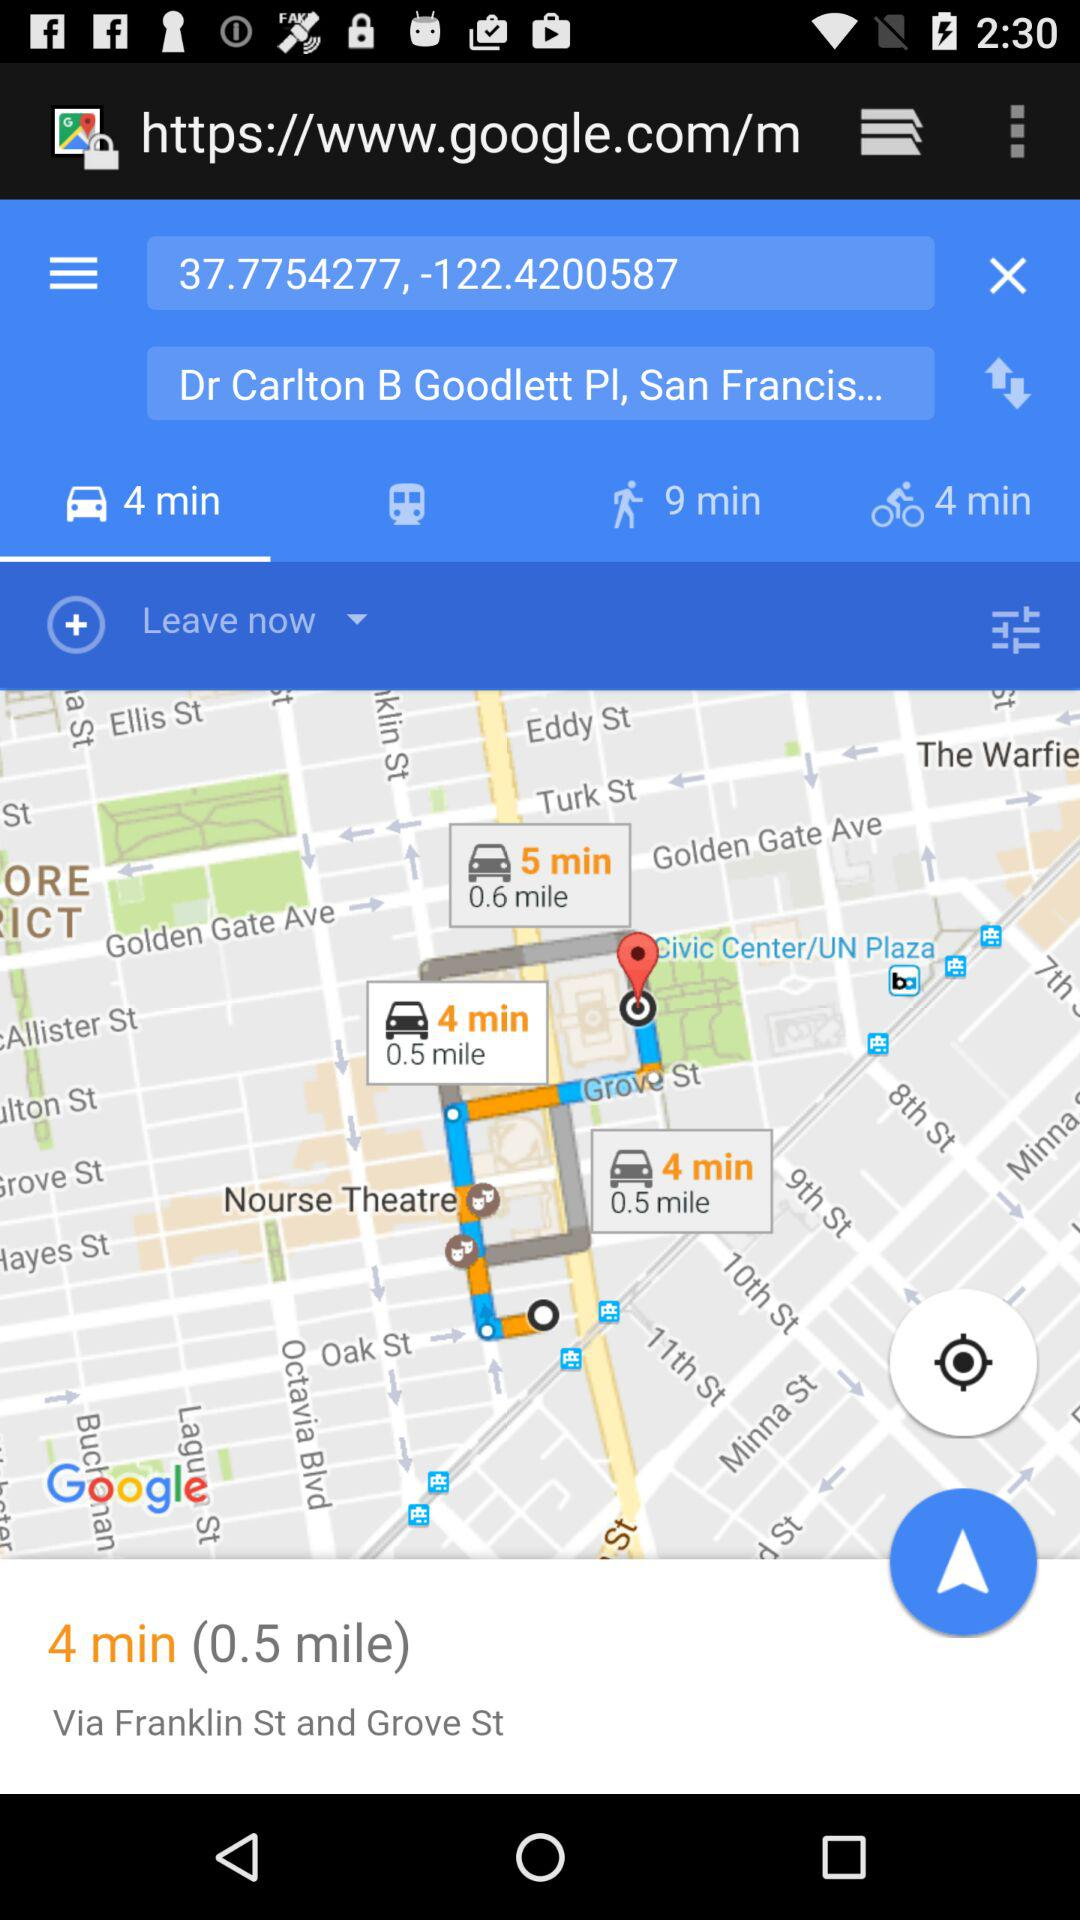How much time is taken to reach Dr. Carlton B. Goodlett PL, San Francisco by walking? The time taken is 9 minutes. 